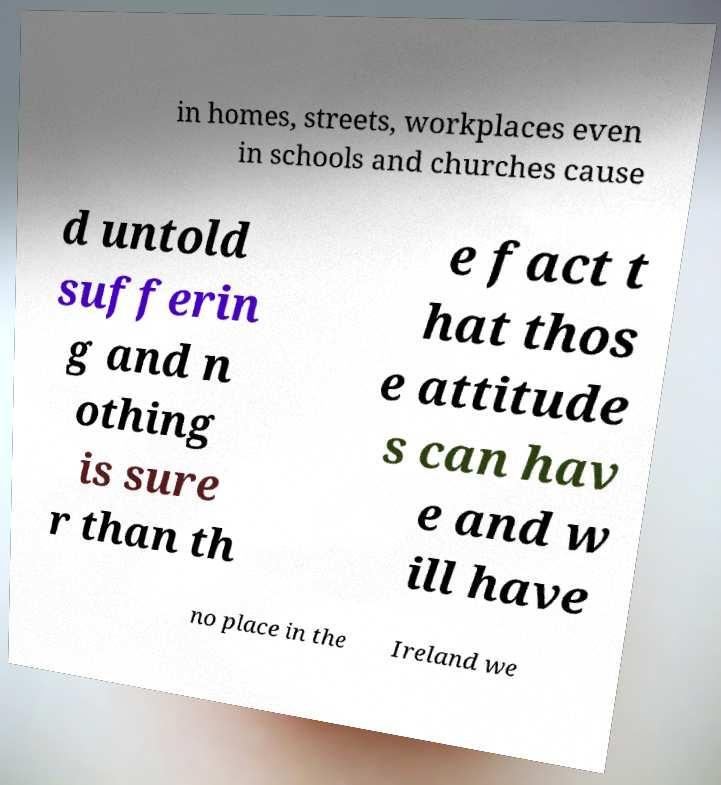Can you accurately transcribe the text from the provided image for me? in homes, streets, workplaces even in schools and churches cause d untold sufferin g and n othing is sure r than th e fact t hat thos e attitude s can hav e and w ill have no place in the Ireland we 